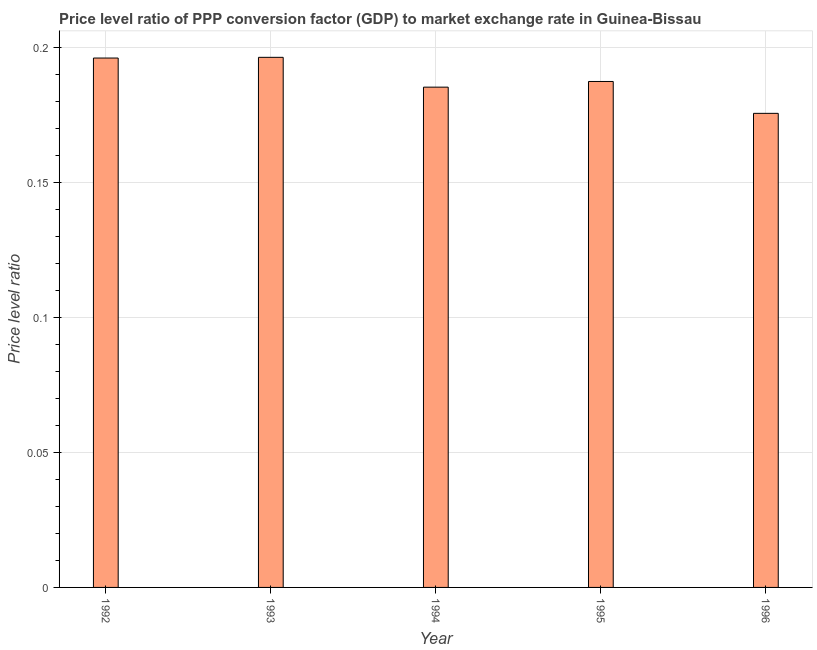What is the title of the graph?
Your answer should be very brief. Price level ratio of PPP conversion factor (GDP) to market exchange rate in Guinea-Bissau. What is the label or title of the Y-axis?
Offer a terse response. Price level ratio. What is the price level ratio in 1996?
Provide a short and direct response. 0.18. Across all years, what is the maximum price level ratio?
Offer a terse response. 0.2. Across all years, what is the minimum price level ratio?
Give a very brief answer. 0.18. What is the sum of the price level ratio?
Offer a very short reply. 0.94. What is the difference between the price level ratio in 1992 and 1995?
Provide a succinct answer. 0.01. What is the average price level ratio per year?
Offer a very short reply. 0.19. What is the median price level ratio?
Offer a very short reply. 0.19. What is the ratio of the price level ratio in 1992 to that in 1995?
Ensure brevity in your answer.  1.05. Is the price level ratio in 1993 less than that in 1995?
Offer a terse response. No. Is the difference between the price level ratio in 1994 and 1996 greater than the difference between any two years?
Your response must be concise. No. What is the difference between the highest and the second highest price level ratio?
Give a very brief answer. 0. Is the sum of the price level ratio in 1993 and 1994 greater than the maximum price level ratio across all years?
Provide a succinct answer. Yes. What is the difference between the highest and the lowest price level ratio?
Give a very brief answer. 0.02. In how many years, is the price level ratio greater than the average price level ratio taken over all years?
Your answer should be very brief. 2. Are all the bars in the graph horizontal?
Your response must be concise. No. How many years are there in the graph?
Offer a terse response. 5. What is the Price level ratio in 1992?
Your answer should be very brief. 0.2. What is the Price level ratio in 1993?
Your answer should be compact. 0.2. What is the Price level ratio in 1994?
Provide a succinct answer. 0.19. What is the Price level ratio of 1995?
Give a very brief answer. 0.19. What is the Price level ratio of 1996?
Your answer should be compact. 0.18. What is the difference between the Price level ratio in 1992 and 1993?
Your answer should be compact. -0. What is the difference between the Price level ratio in 1992 and 1994?
Provide a succinct answer. 0.01. What is the difference between the Price level ratio in 1992 and 1995?
Your answer should be compact. 0.01. What is the difference between the Price level ratio in 1992 and 1996?
Your answer should be very brief. 0.02. What is the difference between the Price level ratio in 1993 and 1994?
Keep it short and to the point. 0.01. What is the difference between the Price level ratio in 1993 and 1995?
Your answer should be compact. 0.01. What is the difference between the Price level ratio in 1993 and 1996?
Offer a very short reply. 0.02. What is the difference between the Price level ratio in 1994 and 1995?
Provide a succinct answer. -0. What is the difference between the Price level ratio in 1994 and 1996?
Your response must be concise. 0.01. What is the difference between the Price level ratio in 1995 and 1996?
Your answer should be very brief. 0.01. What is the ratio of the Price level ratio in 1992 to that in 1993?
Keep it short and to the point. 1. What is the ratio of the Price level ratio in 1992 to that in 1994?
Your answer should be compact. 1.06. What is the ratio of the Price level ratio in 1992 to that in 1995?
Ensure brevity in your answer.  1.05. What is the ratio of the Price level ratio in 1992 to that in 1996?
Ensure brevity in your answer.  1.12. What is the ratio of the Price level ratio in 1993 to that in 1994?
Offer a terse response. 1.06. What is the ratio of the Price level ratio in 1993 to that in 1995?
Your response must be concise. 1.05. What is the ratio of the Price level ratio in 1993 to that in 1996?
Your answer should be compact. 1.12. What is the ratio of the Price level ratio in 1994 to that in 1996?
Offer a very short reply. 1.05. What is the ratio of the Price level ratio in 1995 to that in 1996?
Provide a succinct answer. 1.07. 